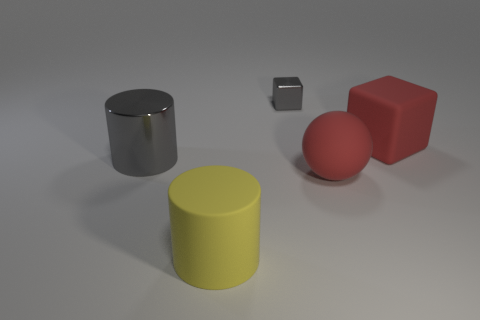Add 3 tiny gray shiny objects. How many objects exist? 8 Subtract all balls. How many objects are left? 4 Add 4 small objects. How many small objects are left? 5 Add 1 rubber objects. How many rubber objects exist? 4 Subtract 0 brown cylinders. How many objects are left? 5 Subtract all large cyan matte balls. Subtract all yellow objects. How many objects are left? 4 